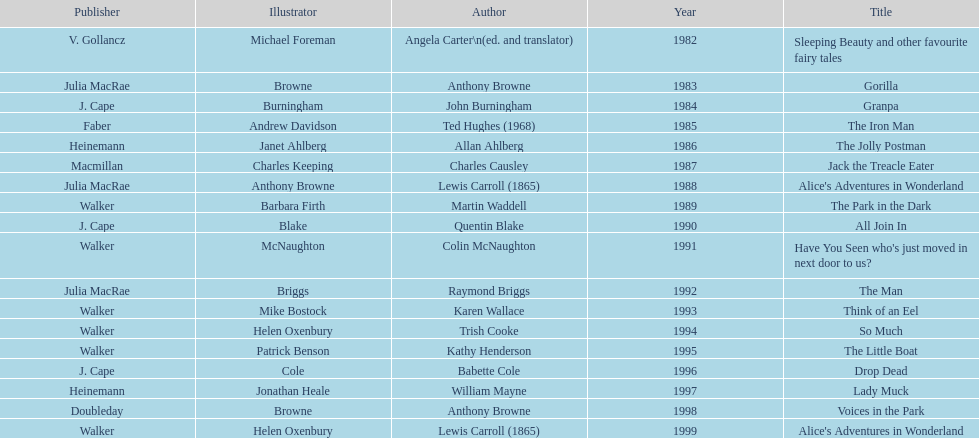How many total titles were published by walker? 5. 